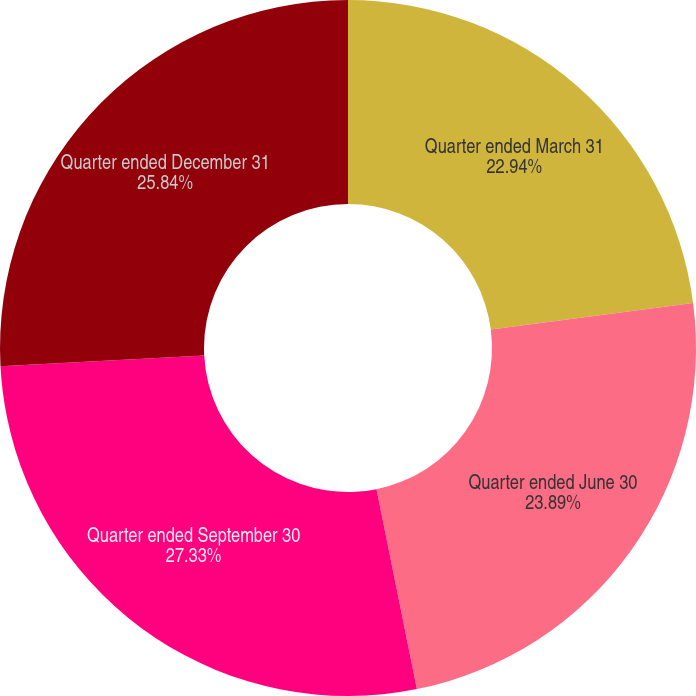<chart> <loc_0><loc_0><loc_500><loc_500><pie_chart><fcel>Quarter ended March 31<fcel>Quarter ended June 30<fcel>Quarter ended September 30<fcel>Quarter ended December 31<nl><fcel>22.94%<fcel>23.89%<fcel>27.33%<fcel>25.84%<nl></chart> 